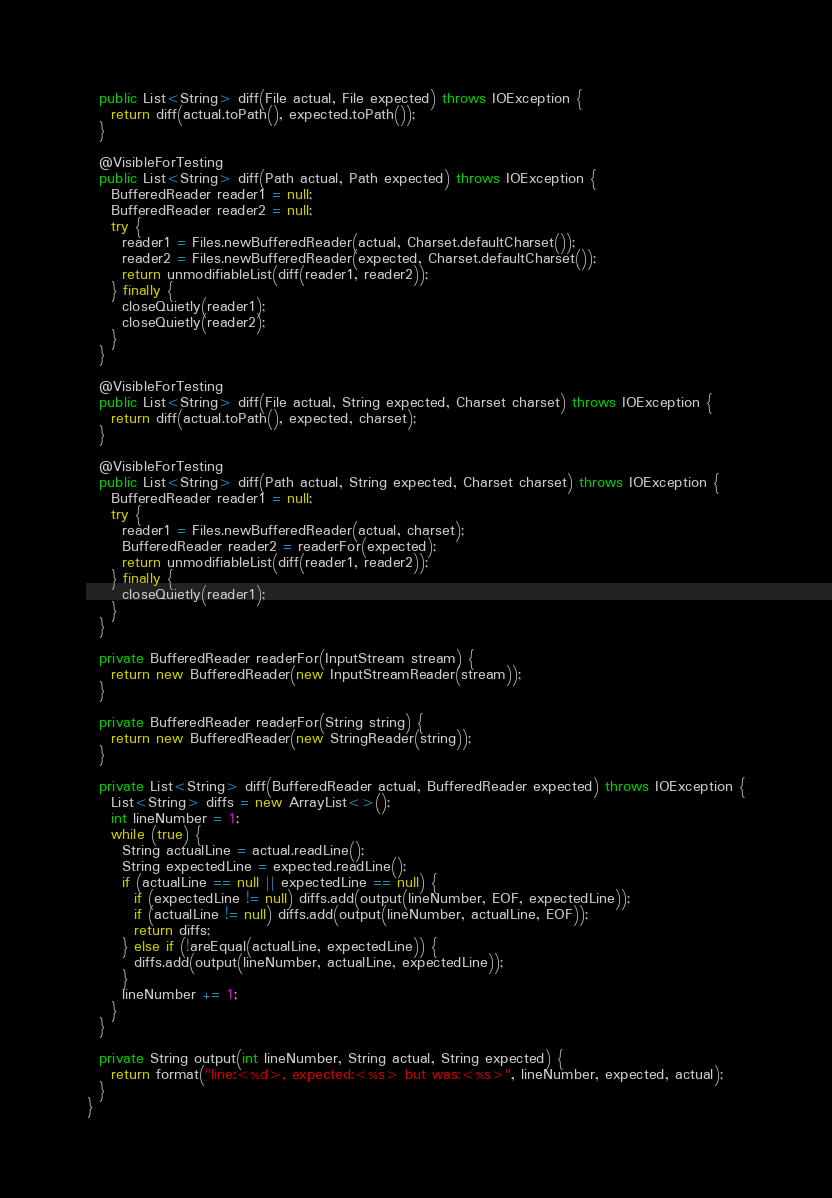<code> <loc_0><loc_0><loc_500><loc_500><_Java_>  public List<String> diff(File actual, File expected) throws IOException {
    return diff(actual.toPath(), expected.toPath());
  }
  
  @VisibleForTesting
  public List<String> diff(Path actual, Path expected) throws IOException {
    BufferedReader reader1 = null;
    BufferedReader reader2 = null;
    try {
      reader1 = Files.newBufferedReader(actual, Charset.defaultCharset());
      reader2 = Files.newBufferedReader(expected, Charset.defaultCharset());
      return unmodifiableList(diff(reader1, reader2));
    } finally {
      closeQuietly(reader1);
      closeQuietly(reader2);
    }
  }

  @VisibleForTesting
  public List<String> diff(File actual, String expected, Charset charset) throws IOException {
    return diff(actual.toPath(), expected, charset);
  }
  
  @VisibleForTesting
  public List<String> diff(Path actual, String expected, Charset charset) throws IOException {
    BufferedReader reader1 = null;
    try {
      reader1 = Files.newBufferedReader(actual, charset); 
      BufferedReader reader2 = readerFor(expected);
      return unmodifiableList(diff(reader1, reader2));
    } finally {
      closeQuietly(reader1);
    }
  }

  private BufferedReader readerFor(InputStream stream) {
    return new BufferedReader(new InputStreamReader(stream));
  }

  private BufferedReader readerFor(String string) {
    return new BufferedReader(new StringReader(string));
  }

  private List<String> diff(BufferedReader actual, BufferedReader expected) throws IOException {
    List<String> diffs = new ArrayList<>();
    int lineNumber = 1;
    while (true) {
      String actualLine = actual.readLine();
      String expectedLine = expected.readLine();
      if (actualLine == null || expectedLine == null) {
        if (expectedLine != null) diffs.add(output(lineNumber, EOF, expectedLine));
        if (actualLine != null) diffs.add(output(lineNumber, actualLine, EOF));
        return diffs;
      } else if (!areEqual(actualLine, expectedLine)) {
        diffs.add(output(lineNumber, actualLine, expectedLine));
      }
      lineNumber += 1;
    }
  }

  private String output(int lineNumber, String actual, String expected) {
    return format("line:<%d>, expected:<%s> but was:<%s>", lineNumber, expected, actual);
  }
}
</code> 